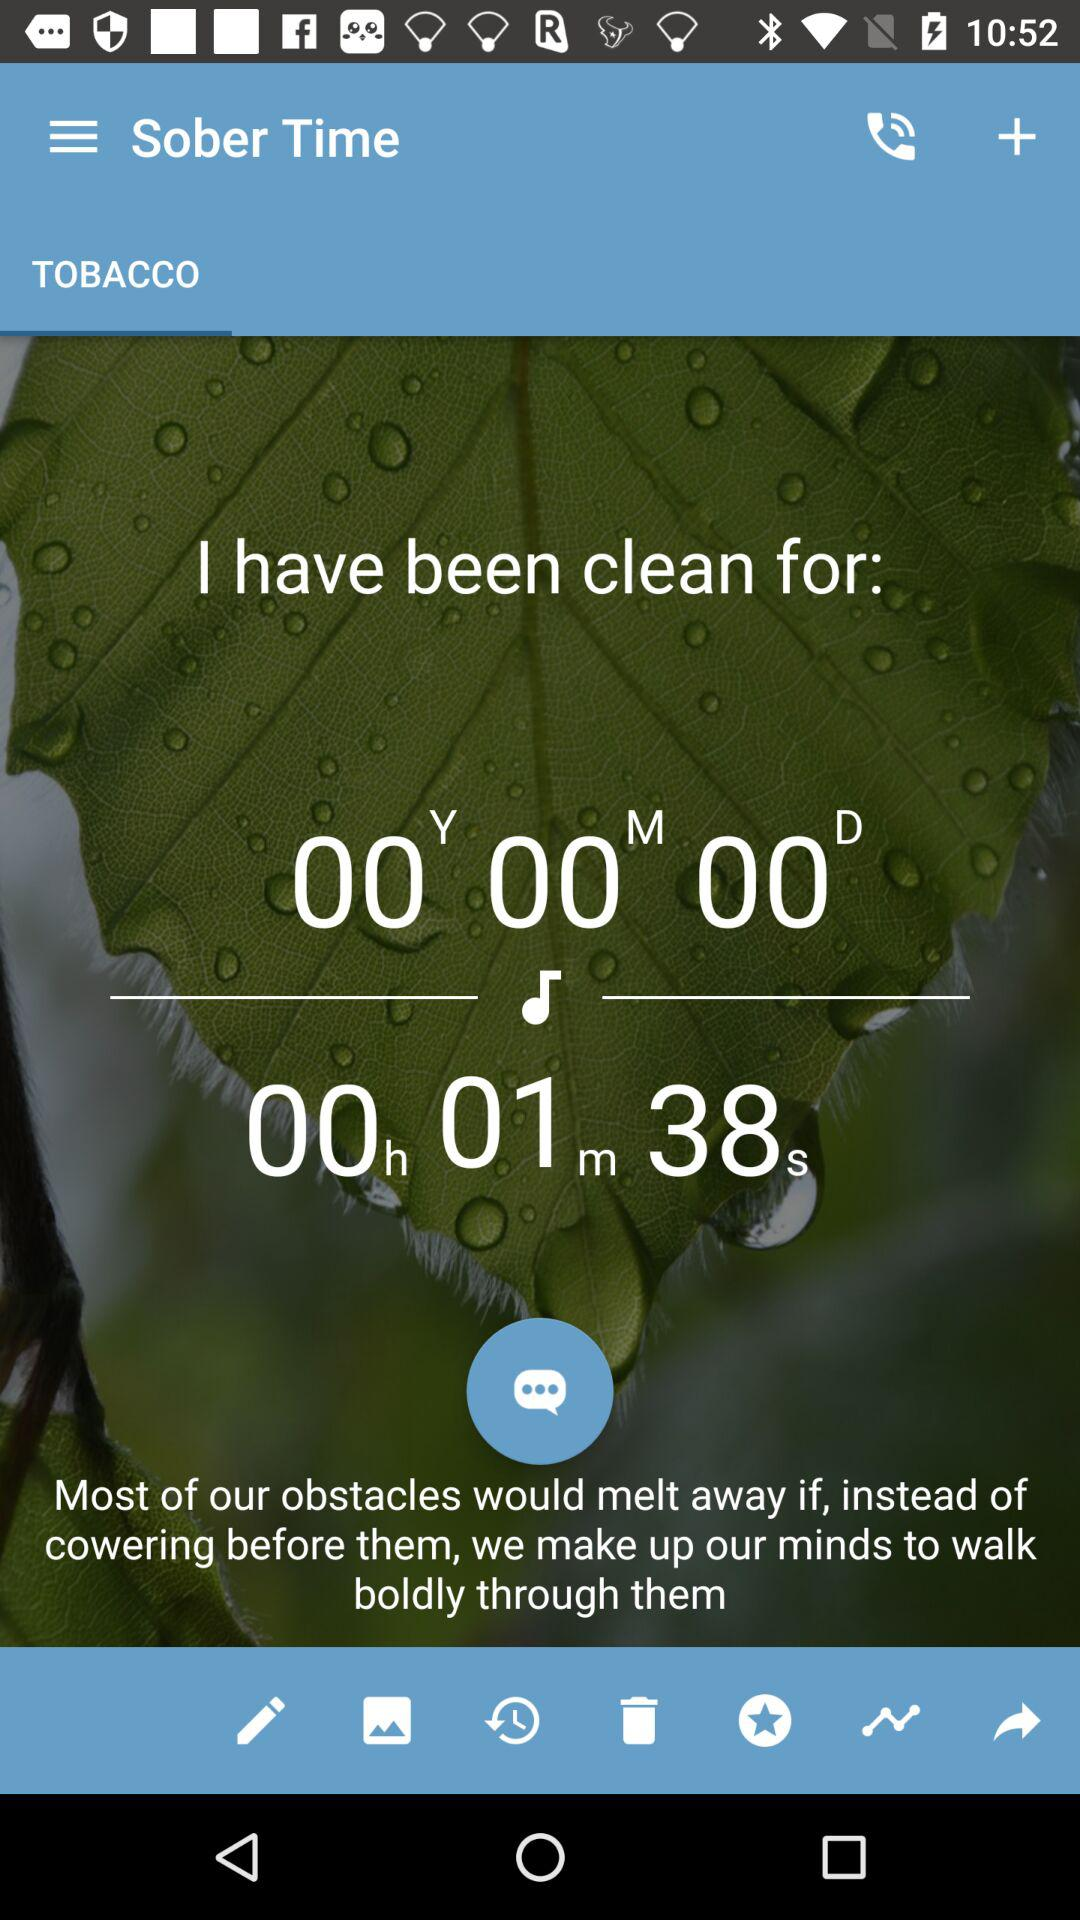Which tab is selected? The selected tab is "TOBACCO". 